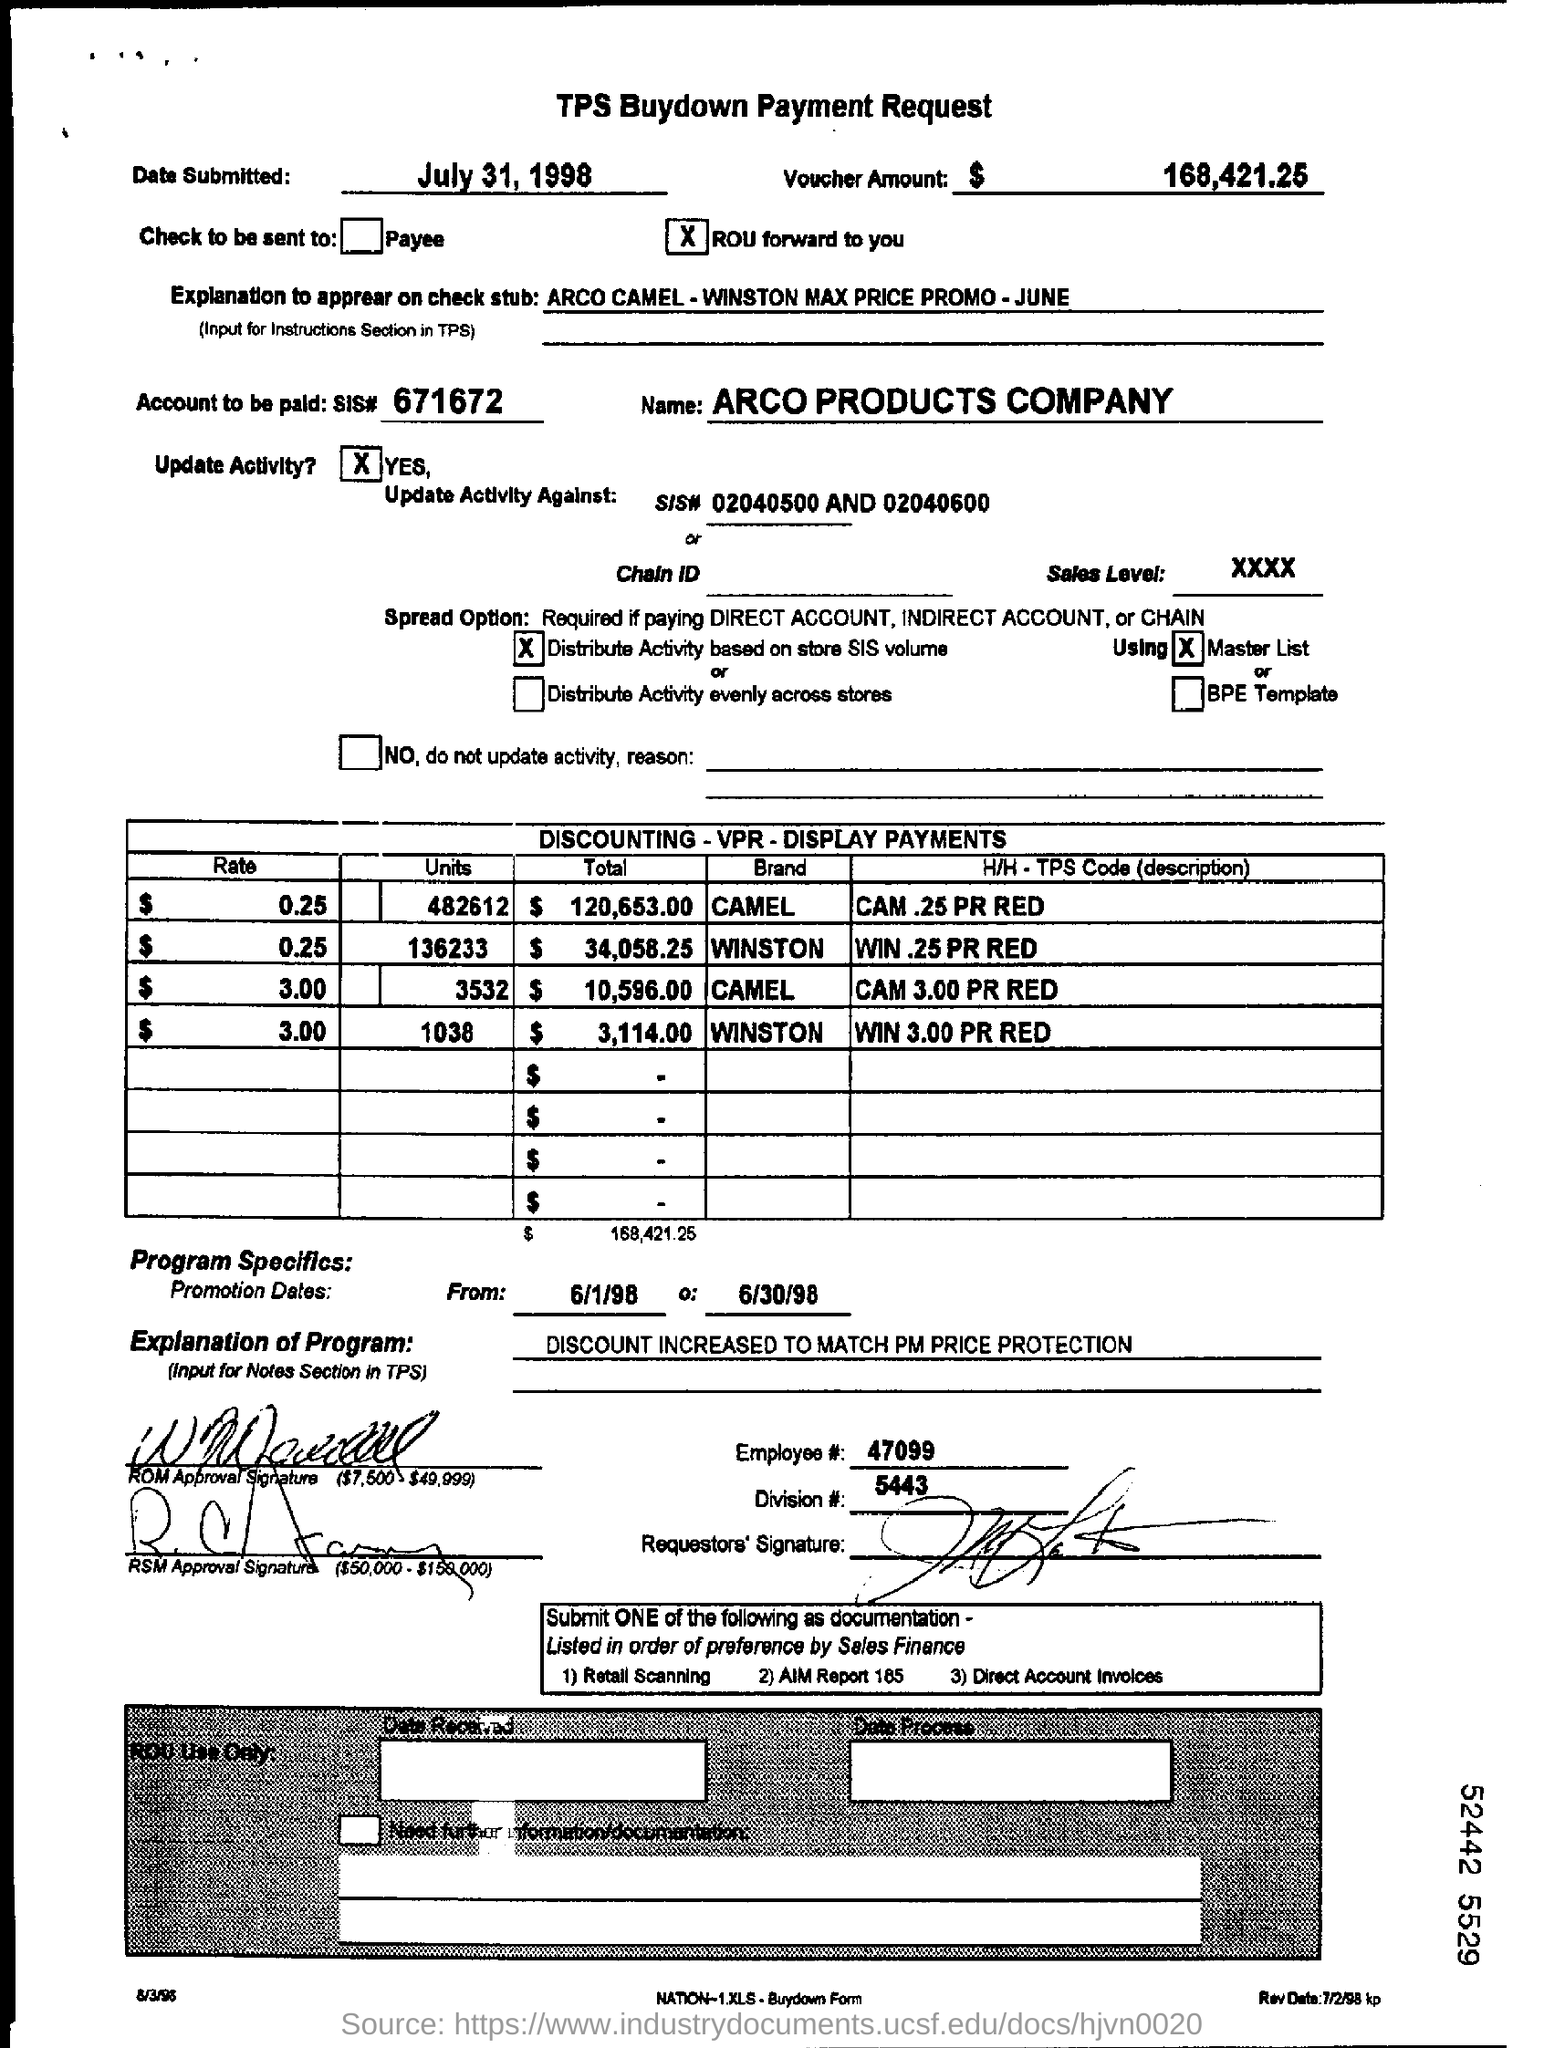When is the tps buydown payment request submitted ?
Your answer should be compact. July 31, 1998. How much is the voucher amount ?
Make the answer very short. $ 168,421.25. What is the employee #?
Offer a terse response. 47099. What is the account to be paid ?
Your answer should be very brief. 671672. What is the name of the company ?
Provide a succinct answer. Arco products company. 